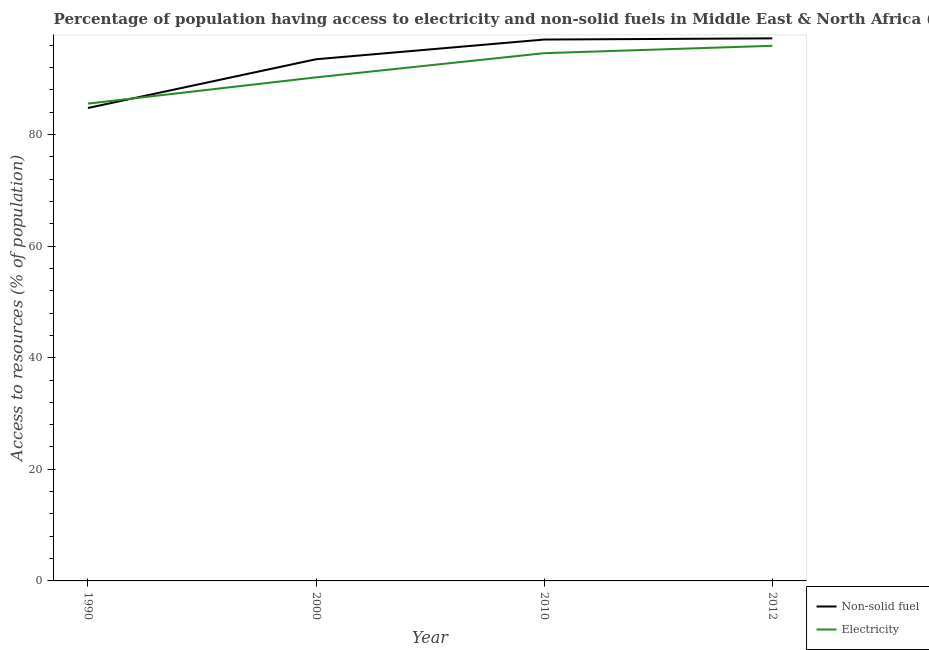How many different coloured lines are there?
Your response must be concise. 2. Does the line corresponding to percentage of population having access to non-solid fuel intersect with the line corresponding to percentage of population having access to electricity?
Your answer should be very brief. Yes. Is the number of lines equal to the number of legend labels?
Your response must be concise. Yes. What is the percentage of population having access to electricity in 2000?
Provide a short and direct response. 90.23. Across all years, what is the maximum percentage of population having access to electricity?
Provide a short and direct response. 95.88. Across all years, what is the minimum percentage of population having access to electricity?
Provide a succinct answer. 85.53. In which year was the percentage of population having access to electricity maximum?
Provide a short and direct response. 2012. In which year was the percentage of population having access to non-solid fuel minimum?
Give a very brief answer. 1990. What is the total percentage of population having access to non-solid fuel in the graph?
Your answer should be very brief. 372.44. What is the difference between the percentage of population having access to electricity in 1990 and that in 2000?
Provide a short and direct response. -4.7. What is the difference between the percentage of population having access to non-solid fuel in 2010 and the percentage of population having access to electricity in 2000?
Your response must be concise. 6.78. What is the average percentage of population having access to electricity per year?
Provide a short and direct response. 91.55. In the year 1990, what is the difference between the percentage of population having access to electricity and percentage of population having access to non-solid fuel?
Offer a terse response. 0.79. What is the ratio of the percentage of population having access to electricity in 2000 to that in 2012?
Your response must be concise. 0.94. What is the difference between the highest and the second highest percentage of population having access to non-solid fuel?
Ensure brevity in your answer.  0.21. What is the difference between the highest and the lowest percentage of population having access to non-solid fuel?
Give a very brief answer. 12.48. Is the percentage of population having access to non-solid fuel strictly greater than the percentage of population having access to electricity over the years?
Your answer should be compact. No. How many years are there in the graph?
Offer a very short reply. 4. What is the difference between two consecutive major ticks on the Y-axis?
Your answer should be very brief. 20. Are the values on the major ticks of Y-axis written in scientific E-notation?
Your answer should be very brief. No. Does the graph contain any zero values?
Provide a succinct answer. No. Does the graph contain grids?
Provide a succinct answer. No. How many legend labels are there?
Your answer should be compact. 2. What is the title of the graph?
Provide a succinct answer. Percentage of population having access to electricity and non-solid fuels in Middle East & North Africa (developing only). Does "% of GNI" appear as one of the legend labels in the graph?
Offer a terse response. No. What is the label or title of the Y-axis?
Offer a terse response. Access to resources (% of population). What is the Access to resources (% of population) in Non-solid fuel in 1990?
Offer a terse response. 84.74. What is the Access to resources (% of population) of Electricity in 1990?
Give a very brief answer. 85.53. What is the Access to resources (% of population) of Non-solid fuel in 2000?
Your answer should be compact. 93.48. What is the Access to resources (% of population) of Electricity in 2000?
Your answer should be compact. 90.23. What is the Access to resources (% of population) of Non-solid fuel in 2010?
Ensure brevity in your answer.  97.01. What is the Access to resources (% of population) of Electricity in 2010?
Your answer should be very brief. 94.57. What is the Access to resources (% of population) in Non-solid fuel in 2012?
Your answer should be compact. 97.22. What is the Access to resources (% of population) of Electricity in 2012?
Offer a very short reply. 95.88. Across all years, what is the maximum Access to resources (% of population) of Non-solid fuel?
Offer a terse response. 97.22. Across all years, what is the maximum Access to resources (% of population) of Electricity?
Your answer should be compact. 95.88. Across all years, what is the minimum Access to resources (% of population) in Non-solid fuel?
Your answer should be compact. 84.74. Across all years, what is the minimum Access to resources (% of population) in Electricity?
Make the answer very short. 85.53. What is the total Access to resources (% of population) in Non-solid fuel in the graph?
Keep it short and to the point. 372.44. What is the total Access to resources (% of population) of Electricity in the graph?
Make the answer very short. 366.21. What is the difference between the Access to resources (% of population) of Non-solid fuel in 1990 and that in 2000?
Offer a terse response. -8.73. What is the difference between the Access to resources (% of population) in Electricity in 1990 and that in 2000?
Your response must be concise. -4.7. What is the difference between the Access to resources (% of population) in Non-solid fuel in 1990 and that in 2010?
Provide a succinct answer. -12.27. What is the difference between the Access to resources (% of population) in Electricity in 1990 and that in 2010?
Offer a terse response. -9.04. What is the difference between the Access to resources (% of population) in Non-solid fuel in 1990 and that in 2012?
Ensure brevity in your answer.  -12.48. What is the difference between the Access to resources (% of population) of Electricity in 1990 and that in 2012?
Offer a very short reply. -10.36. What is the difference between the Access to resources (% of population) of Non-solid fuel in 2000 and that in 2010?
Provide a succinct answer. -3.53. What is the difference between the Access to resources (% of population) of Electricity in 2000 and that in 2010?
Give a very brief answer. -4.34. What is the difference between the Access to resources (% of population) in Non-solid fuel in 2000 and that in 2012?
Offer a very short reply. -3.74. What is the difference between the Access to resources (% of population) of Electricity in 2000 and that in 2012?
Provide a succinct answer. -5.65. What is the difference between the Access to resources (% of population) of Non-solid fuel in 2010 and that in 2012?
Your answer should be very brief. -0.21. What is the difference between the Access to resources (% of population) of Electricity in 2010 and that in 2012?
Provide a short and direct response. -1.32. What is the difference between the Access to resources (% of population) of Non-solid fuel in 1990 and the Access to resources (% of population) of Electricity in 2000?
Offer a terse response. -5.49. What is the difference between the Access to resources (% of population) in Non-solid fuel in 1990 and the Access to resources (% of population) in Electricity in 2010?
Your answer should be compact. -9.82. What is the difference between the Access to resources (% of population) in Non-solid fuel in 1990 and the Access to resources (% of population) in Electricity in 2012?
Your response must be concise. -11.14. What is the difference between the Access to resources (% of population) in Non-solid fuel in 2000 and the Access to resources (% of population) in Electricity in 2010?
Your response must be concise. -1.09. What is the difference between the Access to resources (% of population) of Non-solid fuel in 2000 and the Access to resources (% of population) of Electricity in 2012?
Provide a succinct answer. -2.41. What is the difference between the Access to resources (% of population) in Non-solid fuel in 2010 and the Access to resources (% of population) in Electricity in 2012?
Make the answer very short. 1.12. What is the average Access to resources (% of population) of Non-solid fuel per year?
Offer a very short reply. 93.11. What is the average Access to resources (% of population) in Electricity per year?
Provide a short and direct response. 91.55. In the year 1990, what is the difference between the Access to resources (% of population) of Non-solid fuel and Access to resources (% of population) of Electricity?
Offer a terse response. -0.79. In the year 2000, what is the difference between the Access to resources (% of population) of Non-solid fuel and Access to resources (% of population) of Electricity?
Your response must be concise. 3.24. In the year 2010, what is the difference between the Access to resources (% of population) in Non-solid fuel and Access to resources (% of population) in Electricity?
Provide a succinct answer. 2.44. In the year 2012, what is the difference between the Access to resources (% of population) in Non-solid fuel and Access to resources (% of population) in Electricity?
Give a very brief answer. 1.34. What is the ratio of the Access to resources (% of population) of Non-solid fuel in 1990 to that in 2000?
Keep it short and to the point. 0.91. What is the ratio of the Access to resources (% of population) in Electricity in 1990 to that in 2000?
Ensure brevity in your answer.  0.95. What is the ratio of the Access to resources (% of population) in Non-solid fuel in 1990 to that in 2010?
Your answer should be compact. 0.87. What is the ratio of the Access to resources (% of population) of Electricity in 1990 to that in 2010?
Your answer should be very brief. 0.9. What is the ratio of the Access to resources (% of population) in Non-solid fuel in 1990 to that in 2012?
Give a very brief answer. 0.87. What is the ratio of the Access to resources (% of population) in Electricity in 1990 to that in 2012?
Your answer should be compact. 0.89. What is the ratio of the Access to resources (% of population) of Non-solid fuel in 2000 to that in 2010?
Make the answer very short. 0.96. What is the ratio of the Access to resources (% of population) in Electricity in 2000 to that in 2010?
Keep it short and to the point. 0.95. What is the ratio of the Access to resources (% of population) of Non-solid fuel in 2000 to that in 2012?
Make the answer very short. 0.96. What is the ratio of the Access to resources (% of population) of Electricity in 2000 to that in 2012?
Ensure brevity in your answer.  0.94. What is the ratio of the Access to resources (% of population) of Electricity in 2010 to that in 2012?
Offer a terse response. 0.99. What is the difference between the highest and the second highest Access to resources (% of population) in Non-solid fuel?
Your answer should be very brief. 0.21. What is the difference between the highest and the second highest Access to resources (% of population) in Electricity?
Your response must be concise. 1.32. What is the difference between the highest and the lowest Access to resources (% of population) in Non-solid fuel?
Provide a short and direct response. 12.48. What is the difference between the highest and the lowest Access to resources (% of population) in Electricity?
Your answer should be very brief. 10.36. 